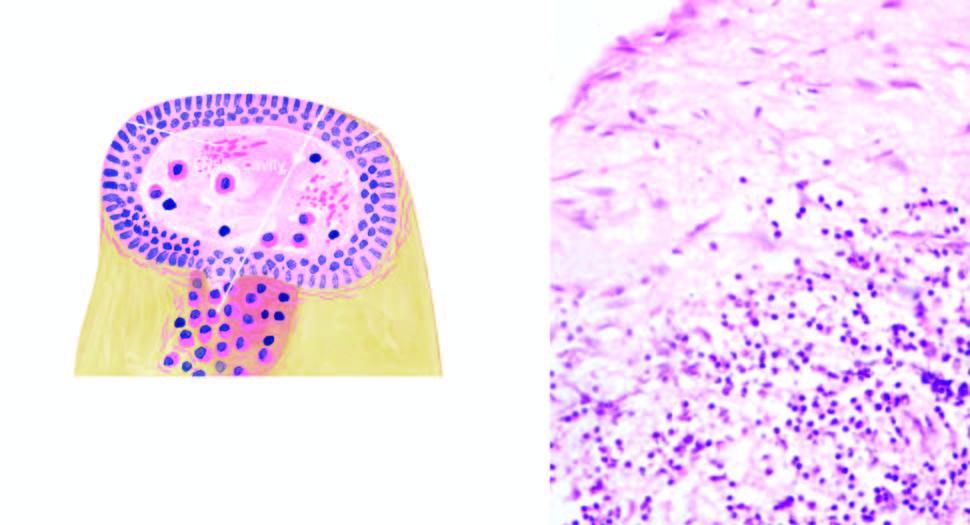s normal non-activated platelet, having open canalicular system and the cytoplasmic organelles densely infiltrated by chronic inflammatory cells, chiefly lymphocytes, plasma cells and macrophages?
Answer the question using a single word or phrase. No 